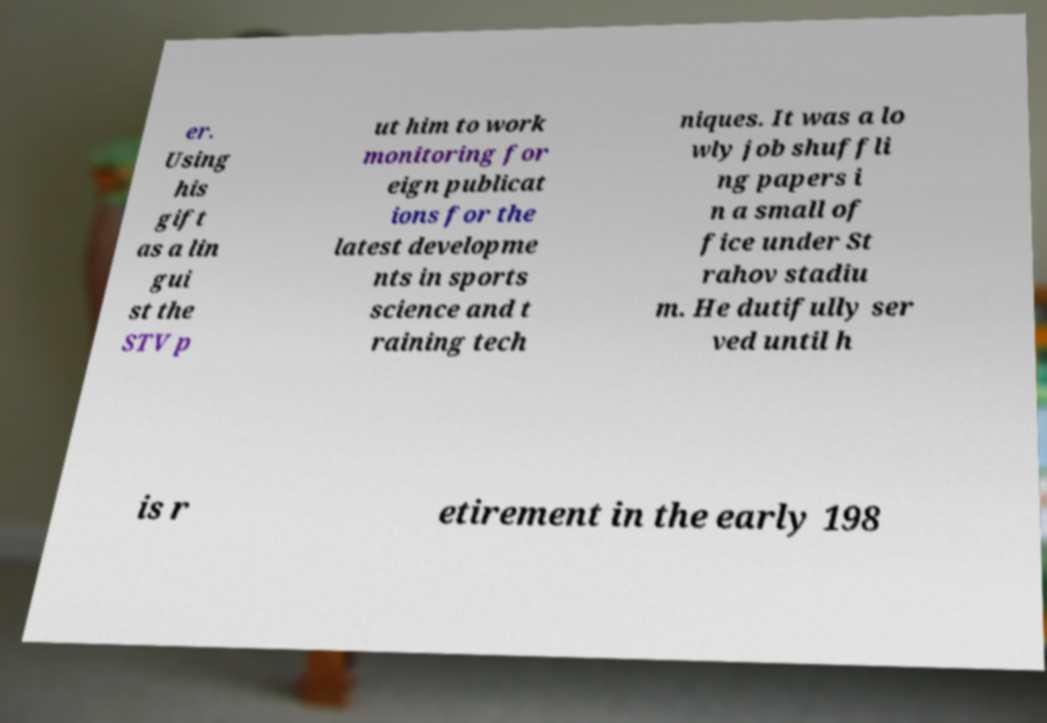Please identify and transcribe the text found in this image. er. Using his gift as a lin gui st the STV p ut him to work monitoring for eign publicat ions for the latest developme nts in sports science and t raining tech niques. It was a lo wly job shuffli ng papers i n a small of fice under St rahov stadiu m. He dutifully ser ved until h is r etirement in the early 198 